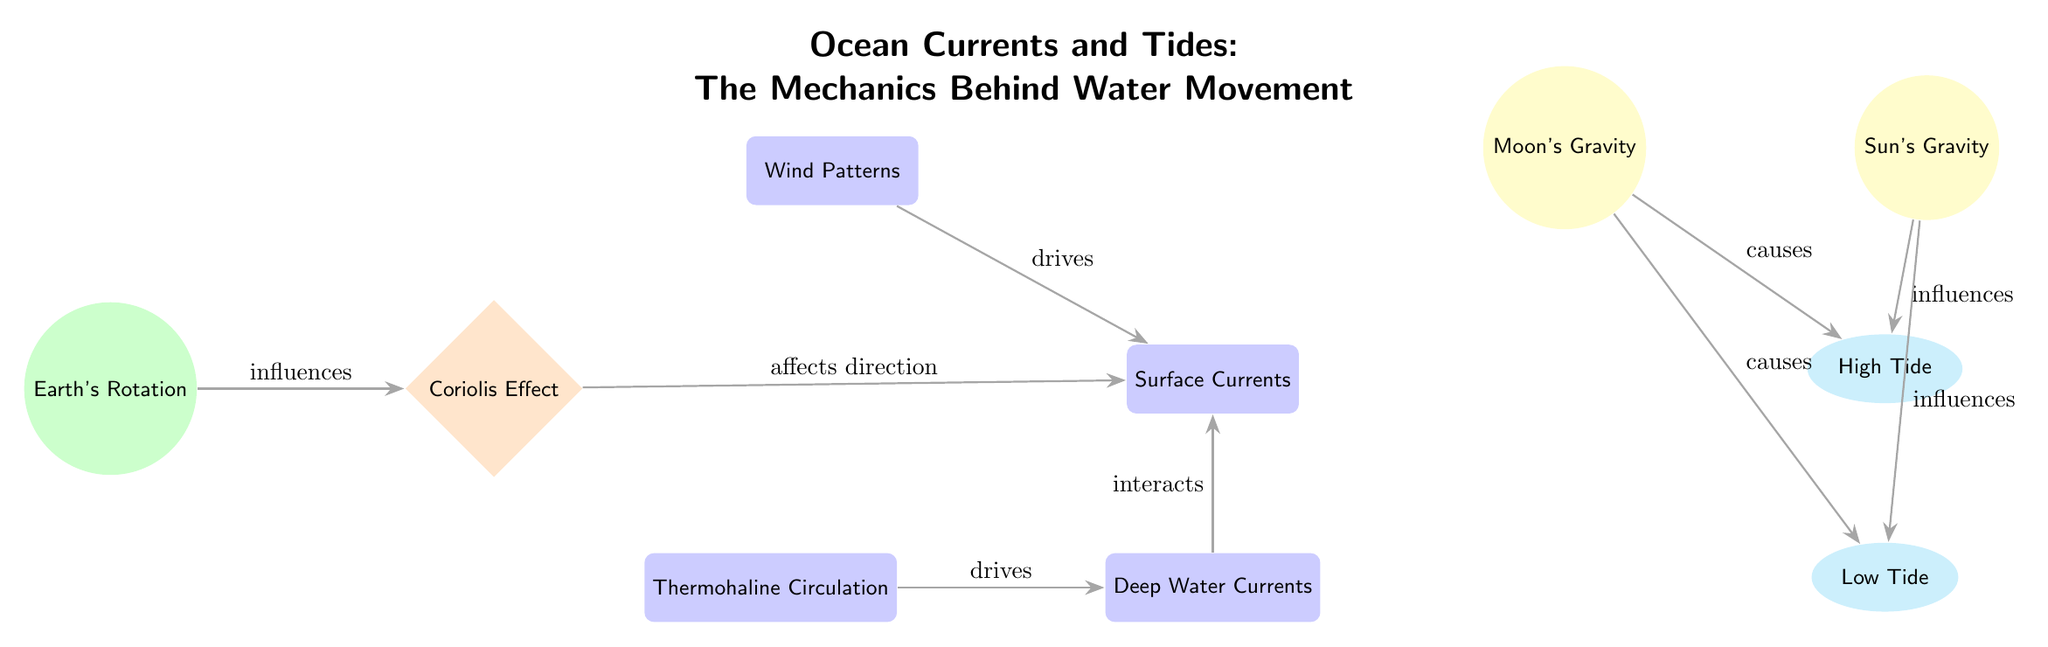What is the main factor influencing the Coriolis Effect? In the diagram, the arrow from Earth's Rotation points to Coriolis Effect and is labeled "influences." This indicates that Earth's Rotation is the primary factor affecting the Coriolis Effect.
Answer: Earth's Rotation Which celestial body causes High Tide? The arrow from Moon's Gravity points to High Tide, with the label "causes." This shows that the Moon's Gravity is responsible for creating High Tide.
Answer: Moon's Gravity How many types of ocean currents are shown in the diagram? The diagram displays three types of ocean currents: Surface Currents, Deep Water Currents, and Thermohaline Circulation. Counting these nodes gives a total of three.
Answer: 3 What drives the Surface Currents? The arrow labeled "drives" points from Wind Patterns to Surface Currents. This indicates that Wind Patterns are the driving force behind Surface Currents.
Answer: Wind Patterns Which type of gravity influences both High Tide and Low Tide? The diagram shows that Solar Gravity has arrows pointing to both High Tide and Low Tide, with the label "influences." This indicates Solar Gravity affects both types of tides.
Answer: Solar Gravity What type of current is influenced by Moon's Gravity? The influence of Moon's Gravity is directed toward both High Tide and Low Tide (noted as "causes"), with the interaction of tides being a type of water movement. Therefore, Moon's Gravity directly influences tidal currents.
Answer: Tides How does Thermohaline Circulation relate to Deep Water Currents? The diagram shows an arrow from Thermohaline Circulation to Deep Water Currents labeled "drives." This means that Thermohaline Circulation is the driving force for Deep Water Currents.
Answer: Drives What is the relationship between Surface Currents and Deep Water Currents? The arrow labeled "interacts" from Deep Water Currents to Surface Currents illustrates that these two types of currents have an interaction, indicating a relationship of influence between them.
Answer: Interacts Which node directly appears after Coriolis Effect in the flow? Following the arrow from Coriolis Effect, the next node is Surface Currents, indicating direct flow after the Coriolis Effect.
Answer: Surface Currents 